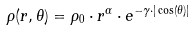<formula> <loc_0><loc_0><loc_500><loc_500>\rho ( r , \theta ) = \rho _ { 0 } \cdot r ^ { \alpha } \cdot e ^ { - \gamma \cdot | \cos ( \theta ) | }</formula> 